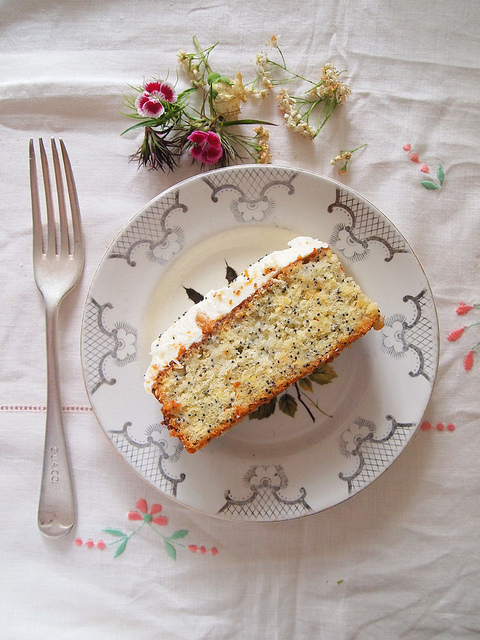Are there any candles or any signs of it being a birthday? The image does not present any visible candles or clear indicators that denote a birthday celebration. 